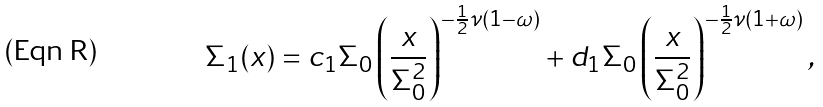<formula> <loc_0><loc_0><loc_500><loc_500>\Sigma _ { 1 } ( x ) = c _ { 1 } \Sigma _ { 0 } \left ( \frac { x } { \Sigma _ { 0 } ^ { 2 } } \right ) ^ { - \frac { 1 } { 2 } \nu ( 1 - \omega ) } + d _ { 1 } \Sigma _ { 0 } \left ( \frac { x } { \Sigma _ { 0 } ^ { 2 } } \right ) ^ { - \frac { 1 } { 2 } \nu ( 1 + \omega ) } ,</formula> 